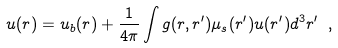<formula> <loc_0><loc_0><loc_500><loc_500>u ( { r } ) = u _ { b } ( { r } ) + \frac { 1 } { 4 \pi } \int g ( { r } , { r } ^ { \prime } ) \mu _ { s } ( { r } ^ { \prime } ) u ( { r } ^ { \prime } ) d ^ { 3 } r ^ { \prime } \ ,</formula> 